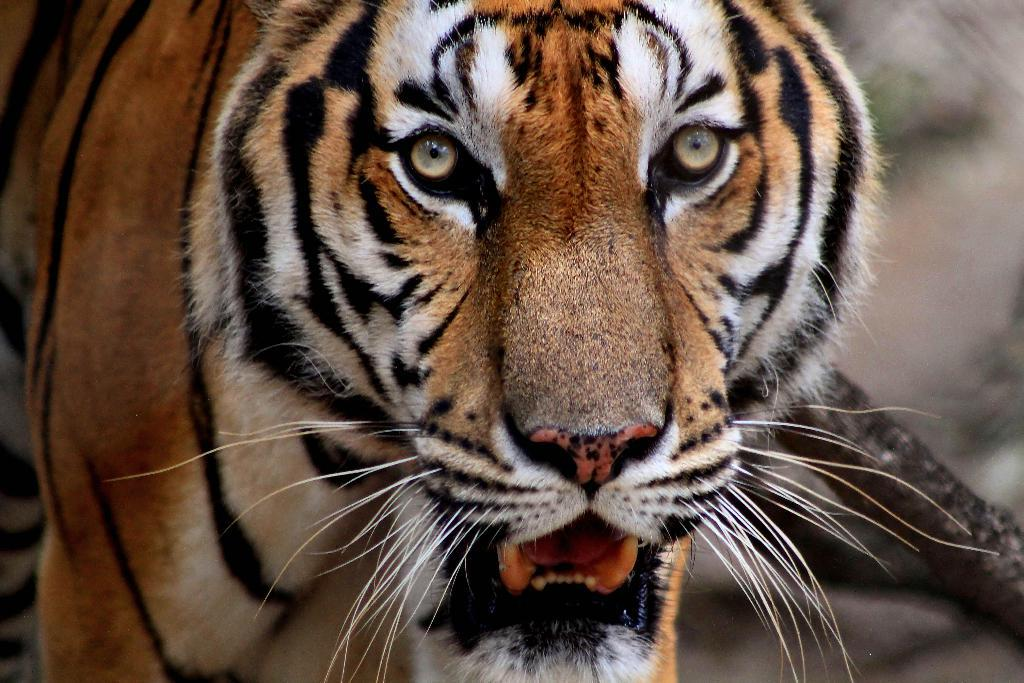What is the main subject in the center of the image? There is a tiger in the center of the image. What type of square pattern can be seen on the tiger's fur in the image? There is no square pattern visible on the tiger's fur in the image. 